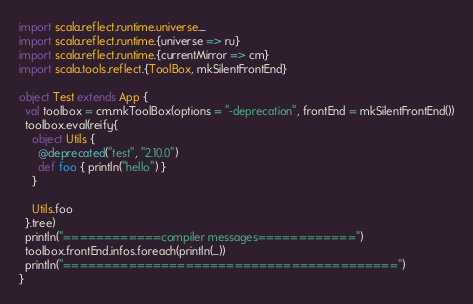Convert code to text. <code><loc_0><loc_0><loc_500><loc_500><_Scala_>import scala.reflect.runtime.universe._
import scala.reflect.runtime.{universe => ru}
import scala.reflect.runtime.{currentMirror => cm}
import scala.tools.reflect.{ToolBox, mkSilentFrontEnd}

object Test extends App {
  val toolbox = cm.mkToolBox(options = "-deprecation", frontEnd = mkSilentFrontEnd())
  toolbox.eval(reify{
    object Utils {
      @deprecated("test", "2.10.0")
      def foo { println("hello") }
    }

    Utils.foo
  }.tree)
  println("============compiler messages============")
  toolbox.frontEnd.infos.foreach(println(_))
  println("=========================================")
}</code> 